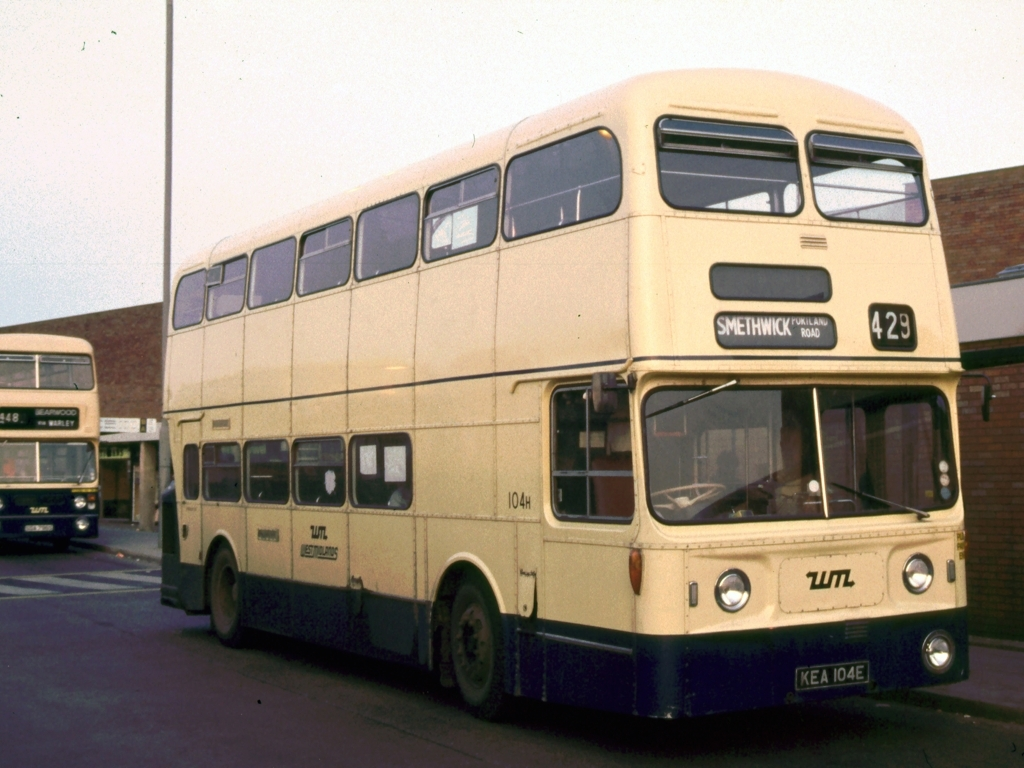Describe the setting where the bus is located. The bus is parked in what appears to be a bus depot or station. The environment looks urban, and there's another bus visible in the background, also likely waiting for its next route or undergoing maintenance. The overall ambiance suggests a hub for city or regional bus transportation, possibly from a past decade judging by the bus design and colors. 